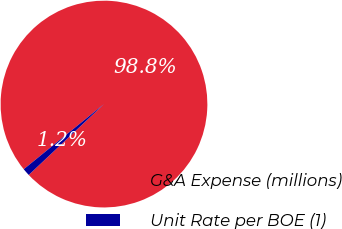Convert chart. <chart><loc_0><loc_0><loc_500><loc_500><pie_chart><fcel>G&A Expense (millions)<fcel>Unit Rate per BOE (1)<nl><fcel>98.83%<fcel>1.17%<nl></chart> 